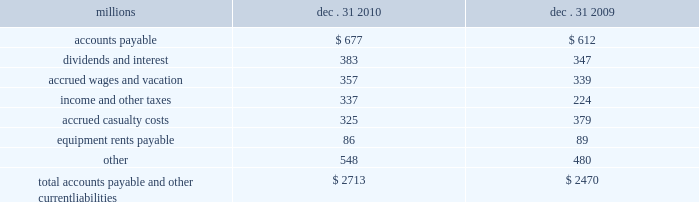Assets held under capital leases are recorded at the lower of the net present value of the minimum lease payments or the fair value of the leased asset at the inception of the lease .
Amortization expense is computed using the straight-line method over the shorter of the estimated useful lives of the assets or the period of the related lease .
12 .
Accounts payable and other current liabilities dec .
31 , dec .
31 , millions 2010 2009 .
13 .
Financial instruments strategy and risk 2013 we may use derivative financial instruments in limited instances for other than trading purposes to assist in managing our overall exposure to fluctuations in interest rates and fuel prices .
We are not a party to leveraged derivatives and , by policy , do not use derivative financial instruments for speculative purposes .
Derivative financial instruments qualifying for hedge accounting must maintain a specified level of effectiveness between the hedging instrument and the item being hedged , both at inception and throughout the hedged period .
We formally document the nature and relationships between the hedging instruments and hedged items at inception , as well as our risk- management objectives , strategies for undertaking the various hedge transactions , and method of assessing hedge effectiveness .
Changes in the fair market value of derivative financial instruments that do not qualify for hedge accounting are charged to earnings .
We may use swaps , collars , futures , and/or forward contracts to mitigate the risk of adverse movements in interest rates and fuel prices ; however , the use of these derivative financial instruments may limit future benefits from favorable interest rate and fuel price movements .
Market and credit risk 2013 we address market risk related to derivative financial instruments by selecting instruments with value fluctuations that highly correlate with the underlying hedged item .
We manage credit risk related to derivative financial instruments , which is minimal , by requiring high credit standards for counterparties and periodic settlements .
At december 31 , 2010 and 2009 , we were not required to provide collateral , nor had we received collateral , relating to our hedging activities .
Determination of fair value 2013 we determine the fair values of our derivative financial instrument positions based upon current fair values as quoted by recognized dealers or the present value of expected future cash flows .
Interest rate fair value hedges 2013 we manage our overall exposure to fluctuations in interest rates by adjusting the proportion of fixed and floating rate debt instruments within our debt portfolio over a given period .
We generally manage the mix of fixed and floating rate debt through the issuance of targeted amounts of each as debt matures or as we require incremental borrowings .
We employ derivatives , primarily swaps , as one of the tools to obtain the targeted mix .
In addition , we also obtain flexibility in managing interest costs and the interest rate mix within our debt portfolio by evaluating the issuance of and managing outstanding callable fixed-rate debt securities .
Swaps allow us to convert debt from fixed rates to variable rates and thereby hedge the risk of changes in the debt 2019s fair value attributable to the changes in interest rates .
We account for swaps as fair value hedges using the short-cut method ; therefore , we do not record any ineffectiveness within our consolidated financial statements. .
What is the percentage increase of total accounts payable and other current liabilities from 2009-2010? 
Computations: ((2713 - 2470) / 2470)
Answer: 0.09838. 